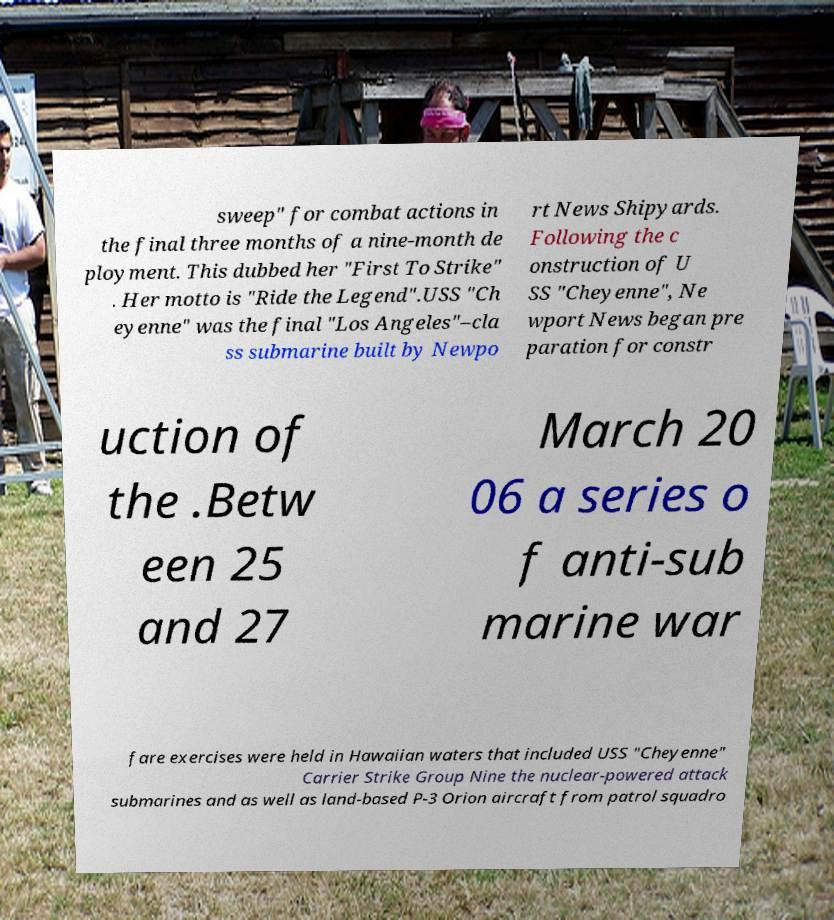Can you accurately transcribe the text from the provided image for me? sweep" for combat actions in the final three months of a nine-month de ployment. This dubbed her "First To Strike" . Her motto is "Ride the Legend".USS "Ch eyenne" was the final "Los Angeles"–cla ss submarine built by Newpo rt News Shipyards. Following the c onstruction of U SS "Cheyenne", Ne wport News began pre paration for constr uction of the .Betw een 25 and 27 March 20 06 a series o f anti-sub marine war fare exercises were held in Hawaiian waters that included USS "Cheyenne" Carrier Strike Group Nine the nuclear-powered attack submarines and as well as land-based P-3 Orion aircraft from patrol squadro 